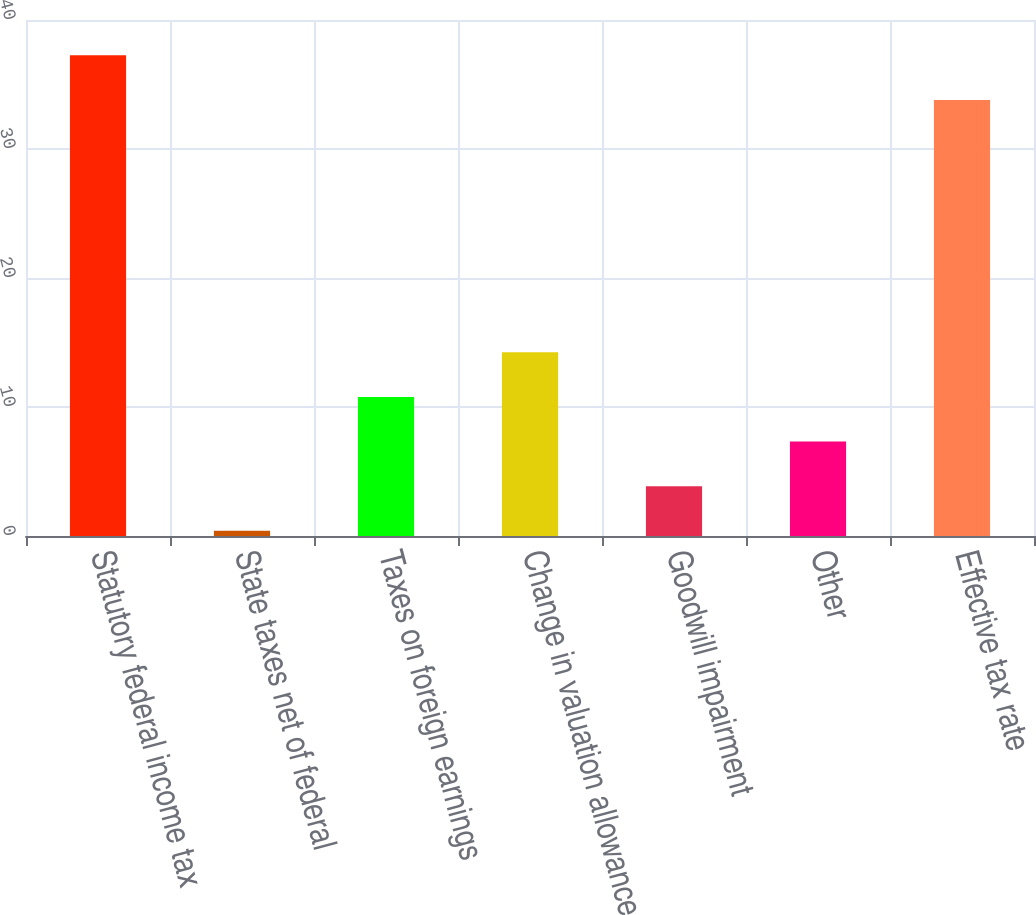<chart> <loc_0><loc_0><loc_500><loc_500><bar_chart><fcel>Statutory federal income tax<fcel>State taxes net of federal<fcel>Taxes on foreign earnings<fcel>Change in valuation allowance<fcel>Goodwill impairment<fcel>Other<fcel>Effective tax rate<nl><fcel>37.26<fcel>0.4<fcel>10.78<fcel>14.24<fcel>3.86<fcel>7.32<fcel>33.8<nl></chart> 